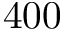Convert formula to latex. <formula><loc_0><loc_0><loc_500><loc_500>4 0 0</formula> 